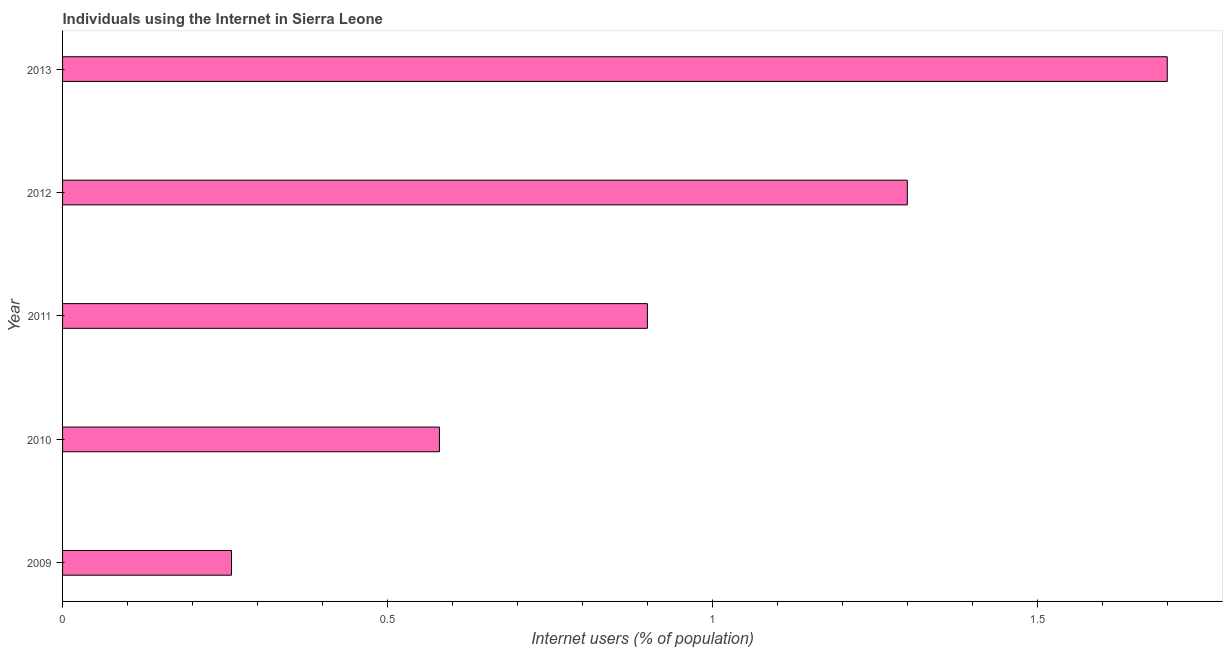Does the graph contain any zero values?
Provide a short and direct response. No. Does the graph contain grids?
Provide a succinct answer. No. What is the title of the graph?
Offer a terse response. Individuals using the Internet in Sierra Leone. What is the label or title of the X-axis?
Offer a terse response. Internet users (% of population). What is the label or title of the Y-axis?
Your response must be concise. Year. Across all years, what is the minimum number of internet users?
Give a very brief answer. 0.26. What is the sum of the number of internet users?
Make the answer very short. 4.74. What is the difference between the number of internet users in 2010 and 2012?
Give a very brief answer. -0.72. What is the average number of internet users per year?
Ensure brevity in your answer.  0.95. In how many years, is the number of internet users greater than 1 %?
Your answer should be very brief. 2. Do a majority of the years between 2009 and 2012 (inclusive) have number of internet users greater than 0.1 %?
Your answer should be very brief. Yes. What is the ratio of the number of internet users in 2010 to that in 2012?
Your response must be concise. 0.45. Is the number of internet users in 2012 less than that in 2013?
Ensure brevity in your answer.  Yes. Is the difference between the number of internet users in 2012 and 2013 greater than the difference between any two years?
Make the answer very short. No. What is the difference between the highest and the second highest number of internet users?
Your response must be concise. 0.4. What is the difference between the highest and the lowest number of internet users?
Provide a succinct answer. 1.44. Are all the bars in the graph horizontal?
Provide a succinct answer. Yes. Are the values on the major ticks of X-axis written in scientific E-notation?
Your answer should be compact. No. What is the Internet users (% of population) in 2009?
Provide a succinct answer. 0.26. What is the Internet users (% of population) in 2010?
Ensure brevity in your answer.  0.58. What is the difference between the Internet users (% of population) in 2009 and 2010?
Your response must be concise. -0.32. What is the difference between the Internet users (% of population) in 2009 and 2011?
Ensure brevity in your answer.  -0.64. What is the difference between the Internet users (% of population) in 2009 and 2012?
Give a very brief answer. -1.04. What is the difference between the Internet users (% of population) in 2009 and 2013?
Your answer should be compact. -1.44. What is the difference between the Internet users (% of population) in 2010 and 2011?
Keep it short and to the point. -0.32. What is the difference between the Internet users (% of population) in 2010 and 2012?
Your response must be concise. -0.72. What is the difference between the Internet users (% of population) in 2010 and 2013?
Offer a terse response. -1.12. What is the difference between the Internet users (% of population) in 2011 and 2012?
Offer a terse response. -0.4. What is the difference between the Internet users (% of population) in 2011 and 2013?
Offer a very short reply. -0.8. What is the difference between the Internet users (% of population) in 2012 and 2013?
Provide a short and direct response. -0.4. What is the ratio of the Internet users (% of population) in 2009 to that in 2010?
Provide a succinct answer. 0.45. What is the ratio of the Internet users (% of population) in 2009 to that in 2011?
Your answer should be compact. 0.29. What is the ratio of the Internet users (% of population) in 2009 to that in 2013?
Provide a short and direct response. 0.15. What is the ratio of the Internet users (% of population) in 2010 to that in 2011?
Offer a very short reply. 0.64. What is the ratio of the Internet users (% of population) in 2010 to that in 2012?
Ensure brevity in your answer.  0.45. What is the ratio of the Internet users (% of population) in 2010 to that in 2013?
Your answer should be very brief. 0.34. What is the ratio of the Internet users (% of population) in 2011 to that in 2012?
Your answer should be very brief. 0.69. What is the ratio of the Internet users (% of population) in 2011 to that in 2013?
Your answer should be very brief. 0.53. What is the ratio of the Internet users (% of population) in 2012 to that in 2013?
Provide a succinct answer. 0.77. 